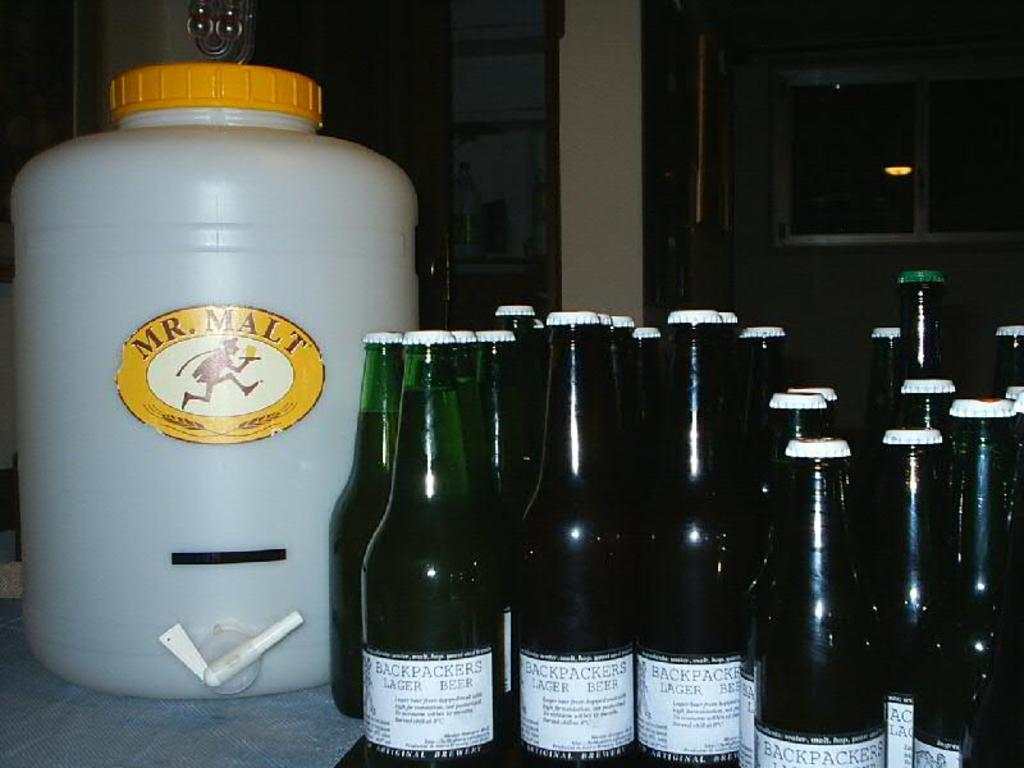<image>
Write a terse but informative summary of the picture. A number of green bottles of Backpacker's Lager sitting next to a large container of Mr. Malt. 